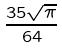Convert formula to latex. <formula><loc_0><loc_0><loc_500><loc_500>\frac { 3 5 \sqrt { \pi } } { 6 4 }</formula> 